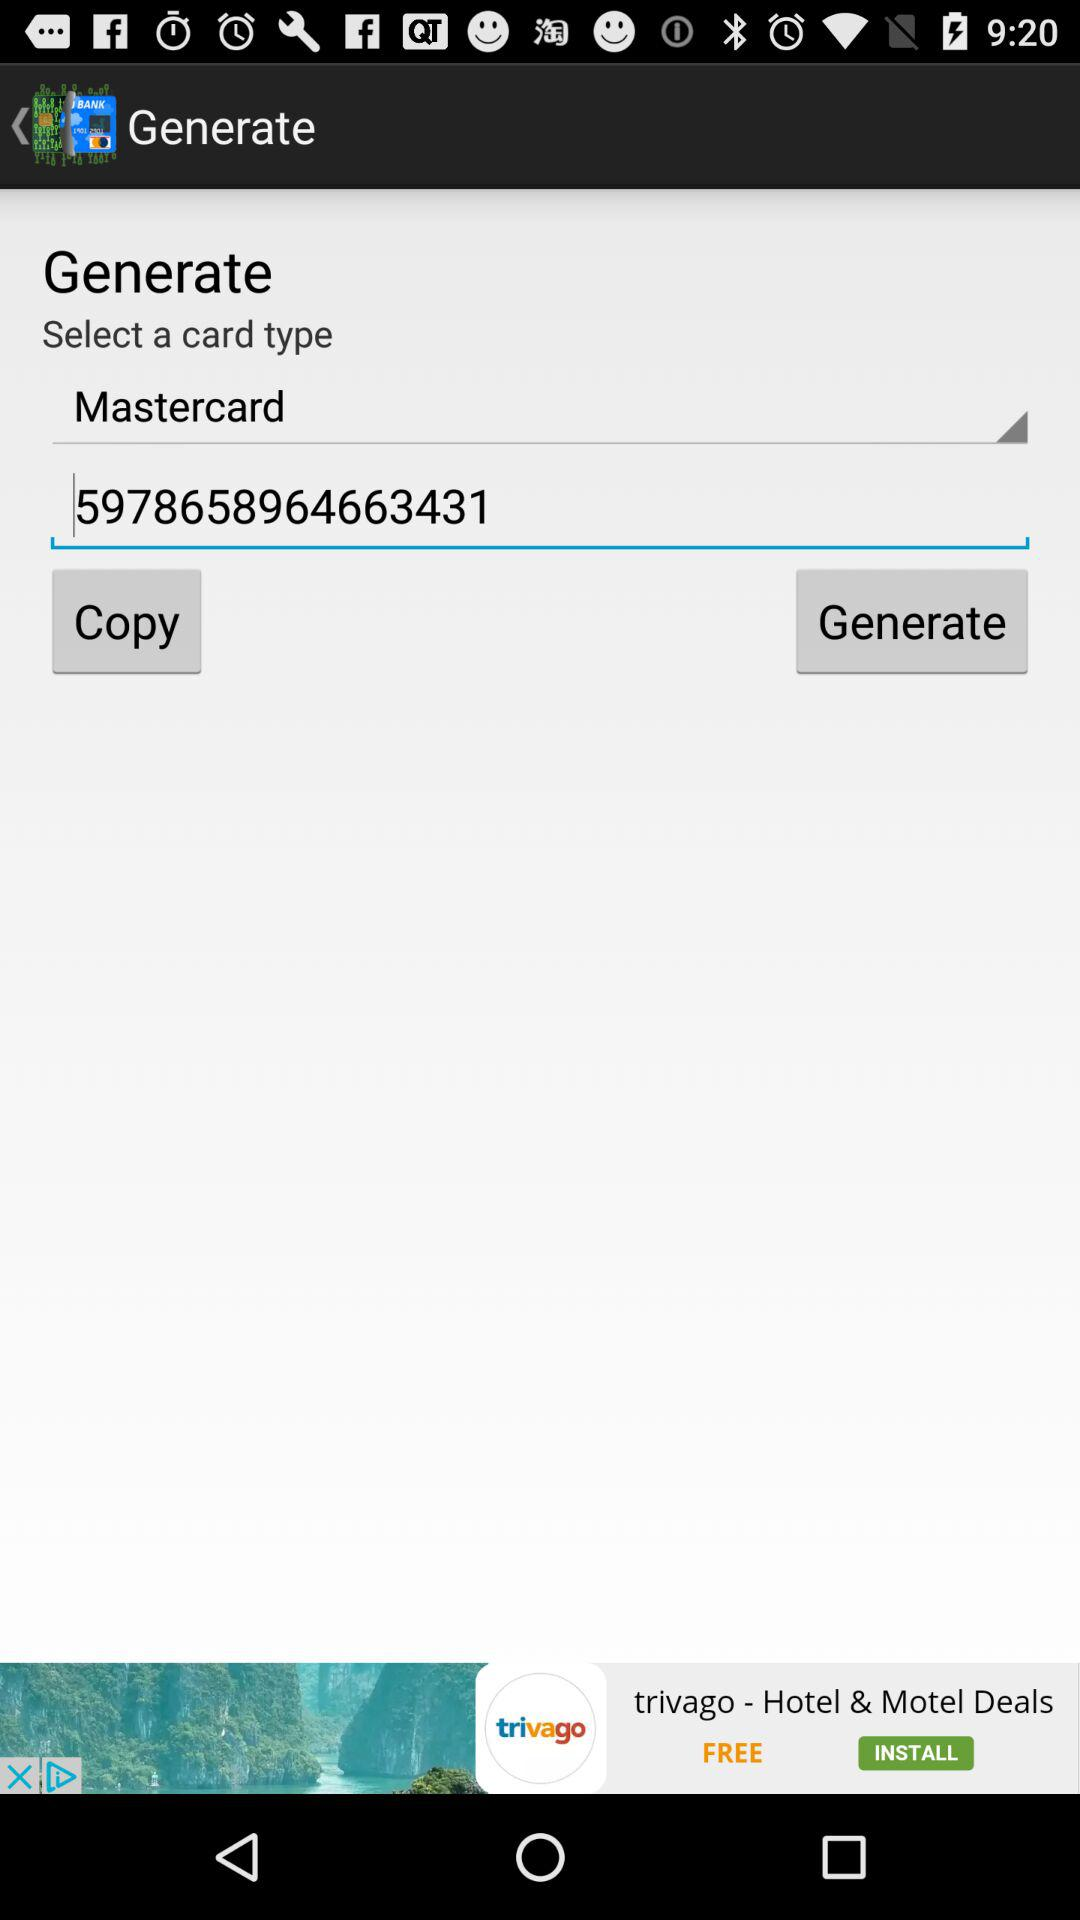Which type of card is it?
Answer the question using a single word or phrase. It is Mastercard. 